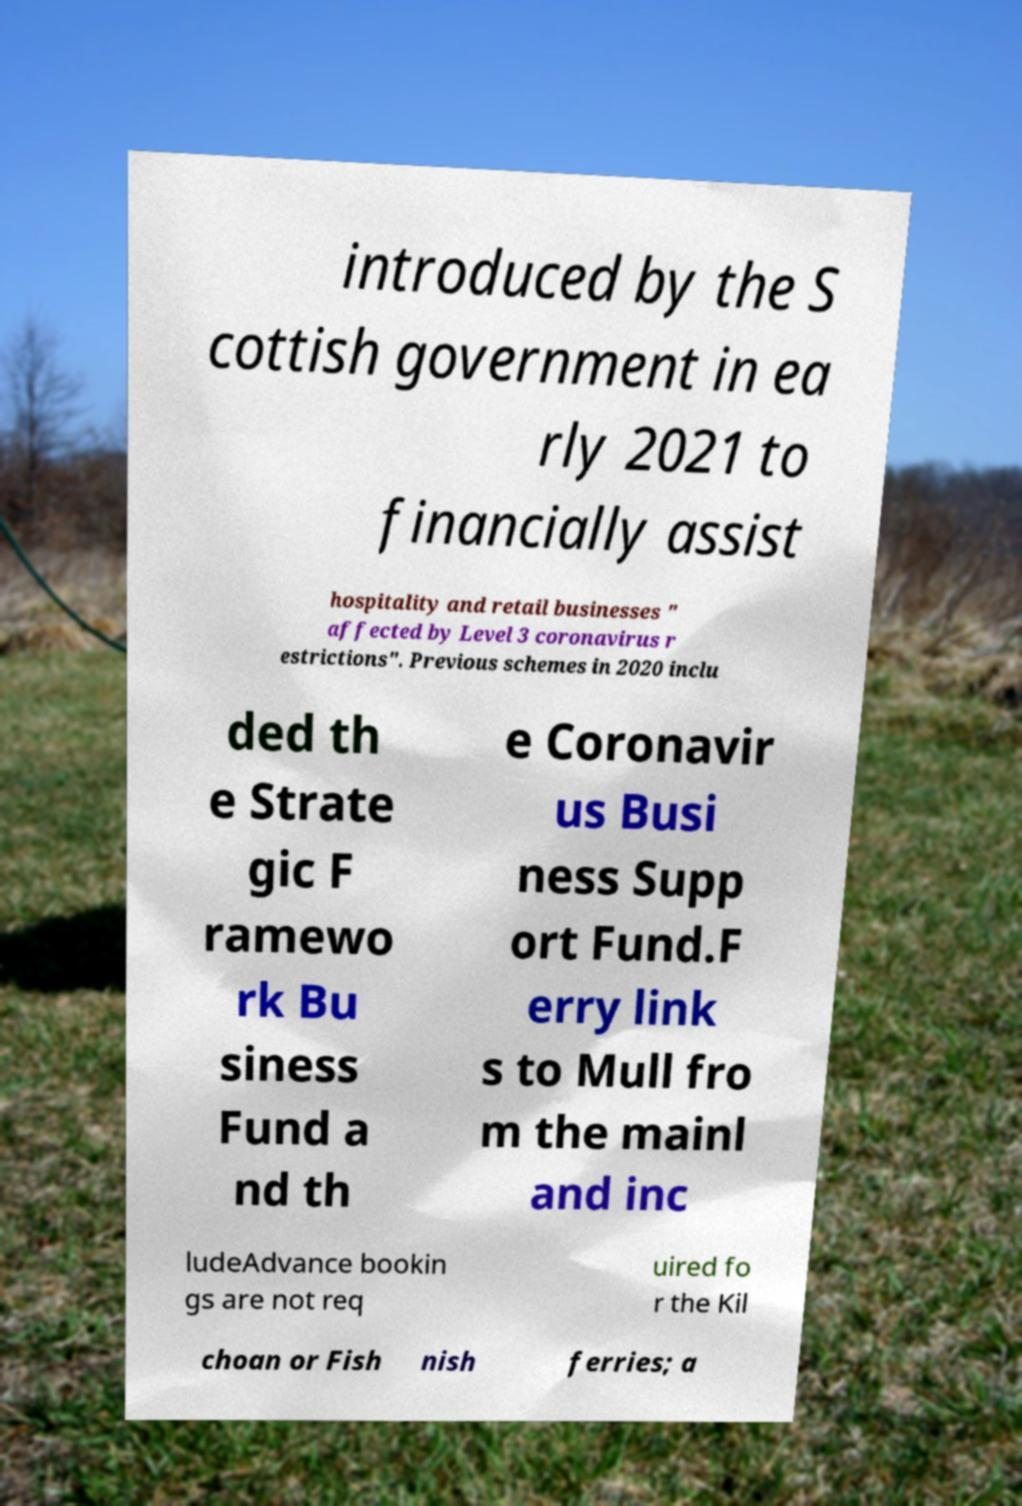I need the written content from this picture converted into text. Can you do that? introduced by the S cottish government in ea rly 2021 to financially assist hospitality and retail businesses " affected by Level 3 coronavirus r estrictions". Previous schemes in 2020 inclu ded th e Strate gic F ramewo rk Bu siness Fund a nd th e Coronavir us Busi ness Supp ort Fund.F erry link s to Mull fro m the mainl and inc ludeAdvance bookin gs are not req uired fo r the Kil choan or Fish nish ferries; a 